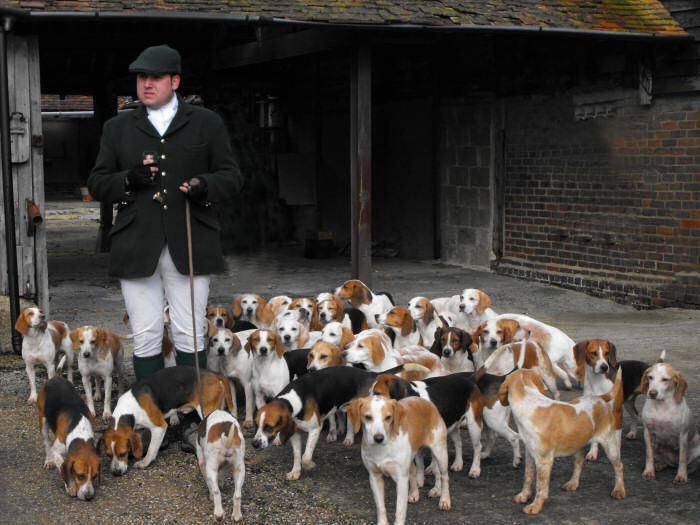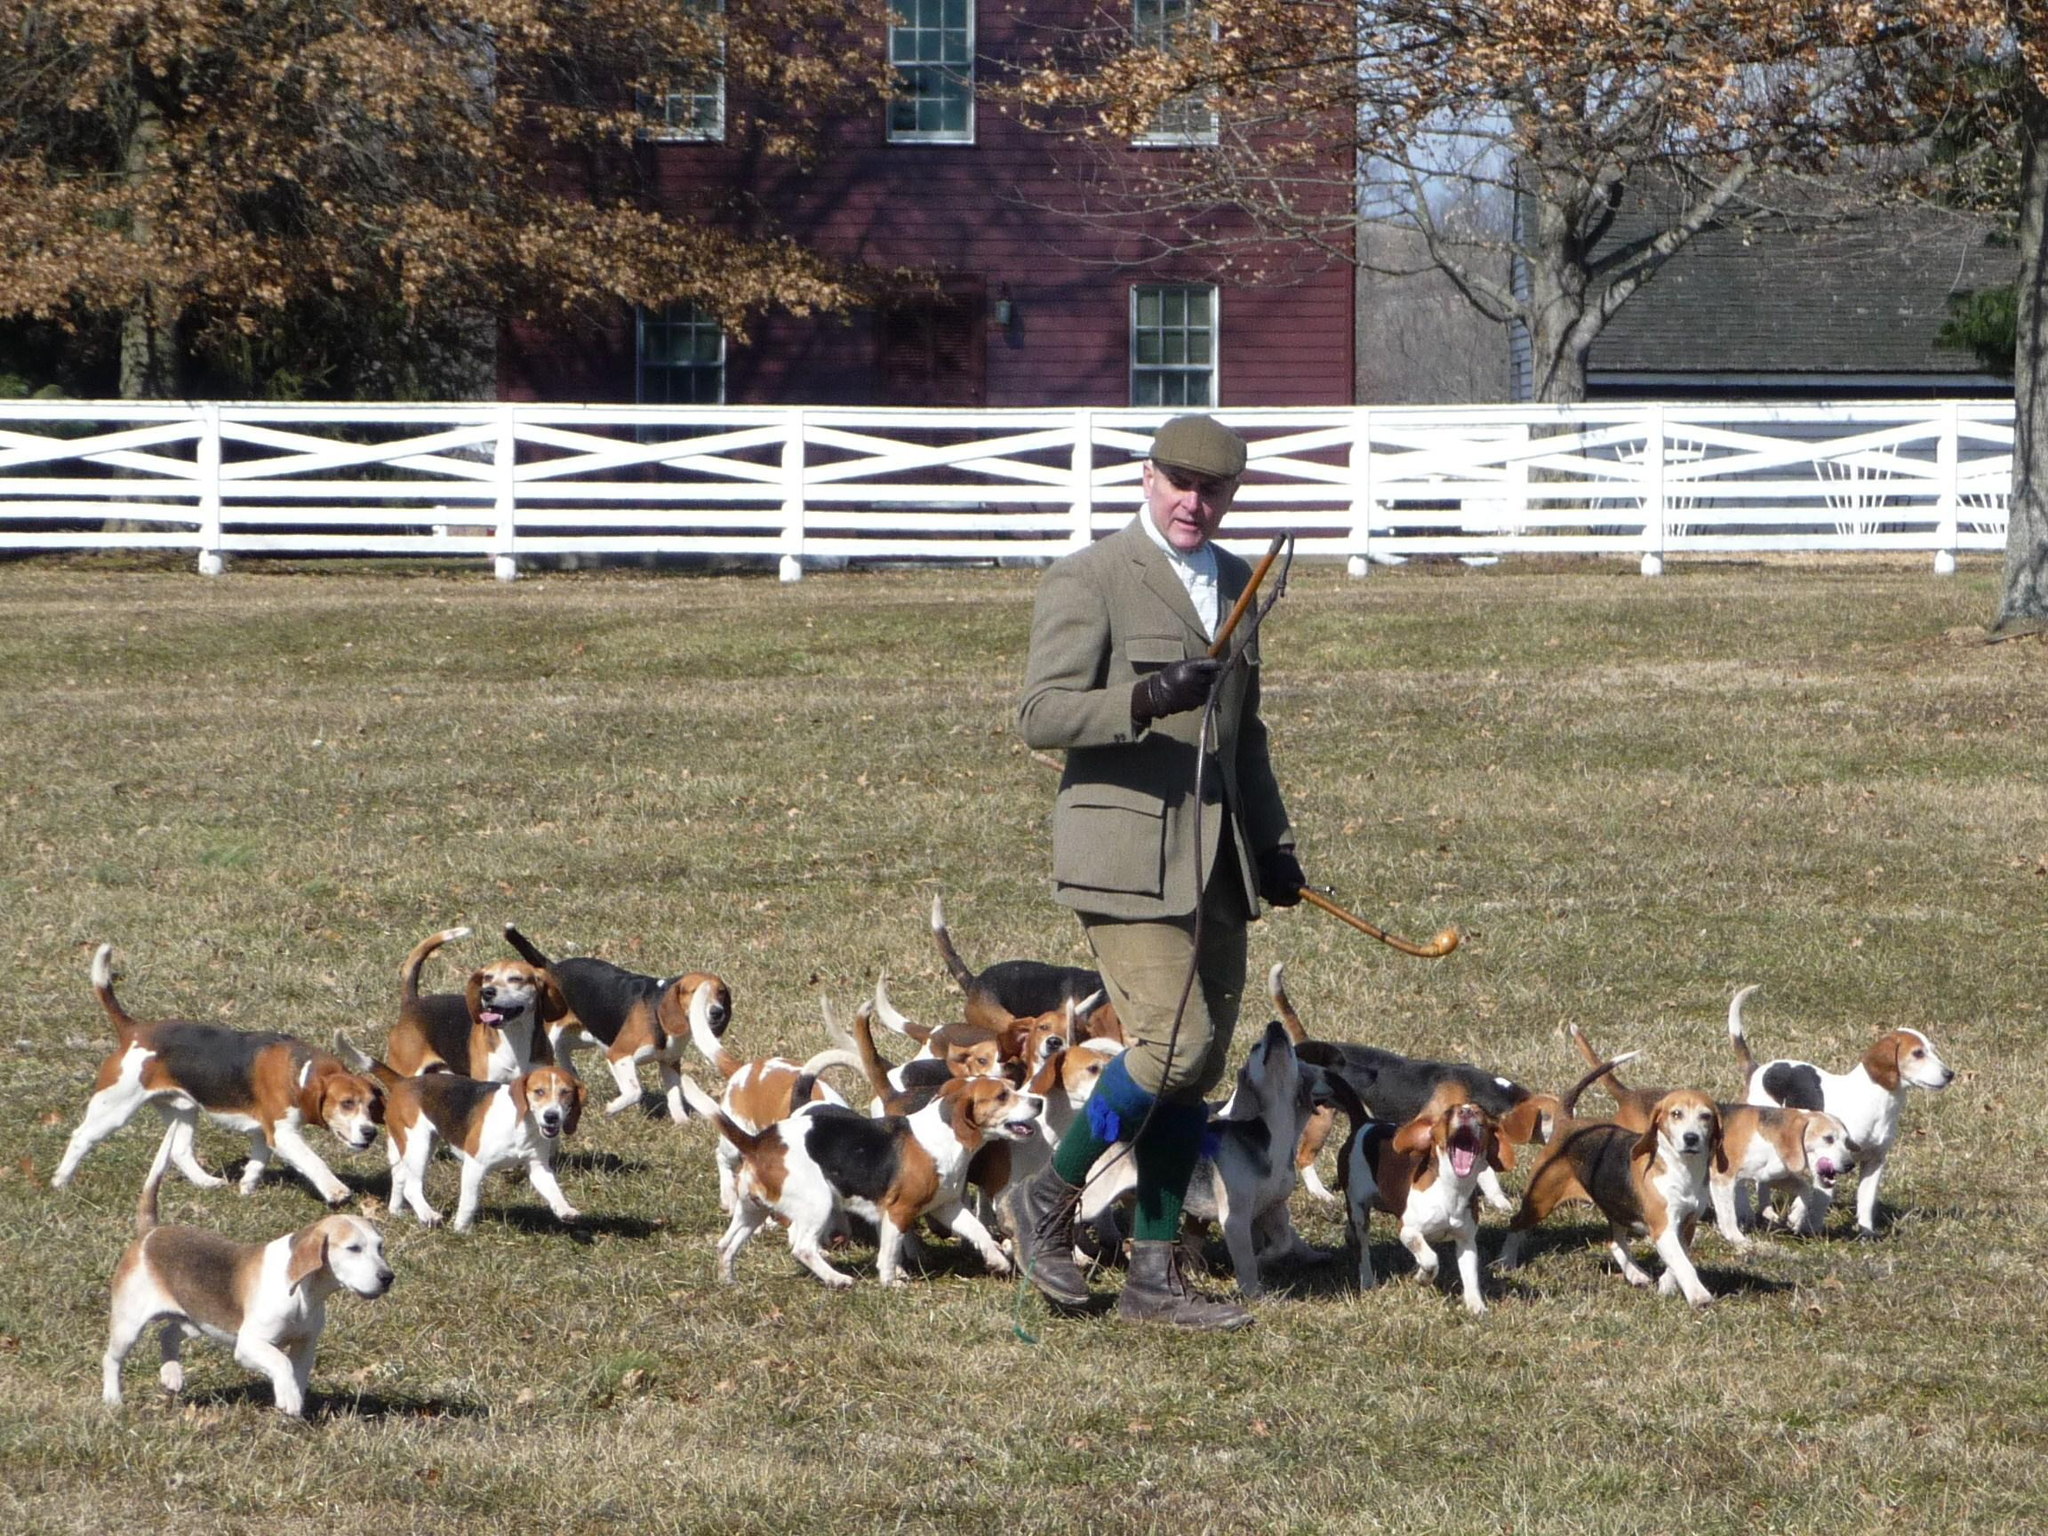The first image is the image on the left, the second image is the image on the right. For the images shown, is this caption "Each image shows a pack of dogs near a man in a blazer and cap holding a whip stick." true? Answer yes or no. Yes. The first image is the image on the left, the second image is the image on the right. For the images displayed, is the sentence "A white fence is visible behind a group of dogs." factually correct? Answer yes or no. Yes. The first image is the image on the left, the second image is the image on the right. Given the left and right images, does the statement "Right image shows a pack of dogs running forward." hold true? Answer yes or no. No. The first image is the image on the left, the second image is the image on the right. Given the left and right images, does the statement "Dogs are running in both pictures." hold true? Answer yes or no. No. 